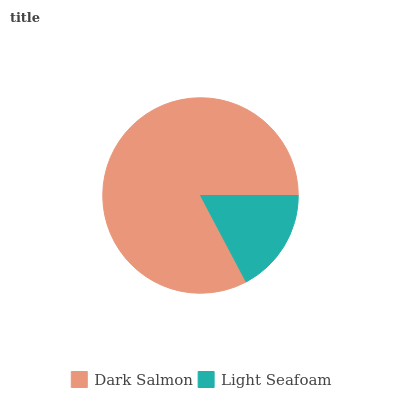Is Light Seafoam the minimum?
Answer yes or no. Yes. Is Dark Salmon the maximum?
Answer yes or no. Yes. Is Light Seafoam the maximum?
Answer yes or no. No. Is Dark Salmon greater than Light Seafoam?
Answer yes or no. Yes. Is Light Seafoam less than Dark Salmon?
Answer yes or no. Yes. Is Light Seafoam greater than Dark Salmon?
Answer yes or no. No. Is Dark Salmon less than Light Seafoam?
Answer yes or no. No. Is Dark Salmon the high median?
Answer yes or no. Yes. Is Light Seafoam the low median?
Answer yes or no. Yes. Is Light Seafoam the high median?
Answer yes or no. No. Is Dark Salmon the low median?
Answer yes or no. No. 